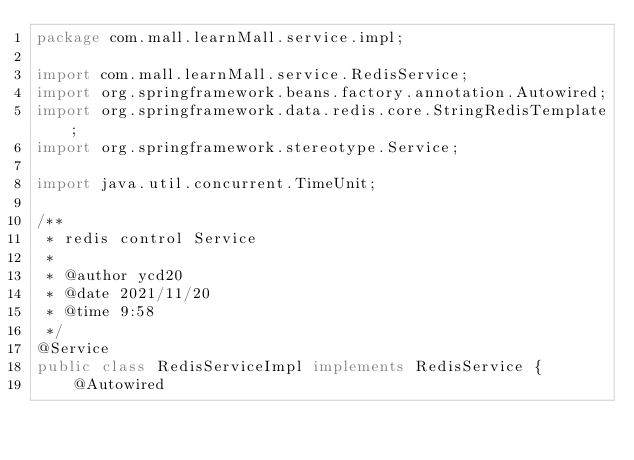<code> <loc_0><loc_0><loc_500><loc_500><_Java_>package com.mall.learnMall.service.impl;

import com.mall.learnMall.service.RedisService;
import org.springframework.beans.factory.annotation.Autowired;
import org.springframework.data.redis.core.StringRedisTemplate;
import org.springframework.stereotype.Service;

import java.util.concurrent.TimeUnit;

/**
 * redis control Service
 *
 * @author ycd20
 * @date 2021/11/20
 * @time 9:58
 */
@Service
public class RedisServiceImpl implements RedisService {
    @Autowired</code> 